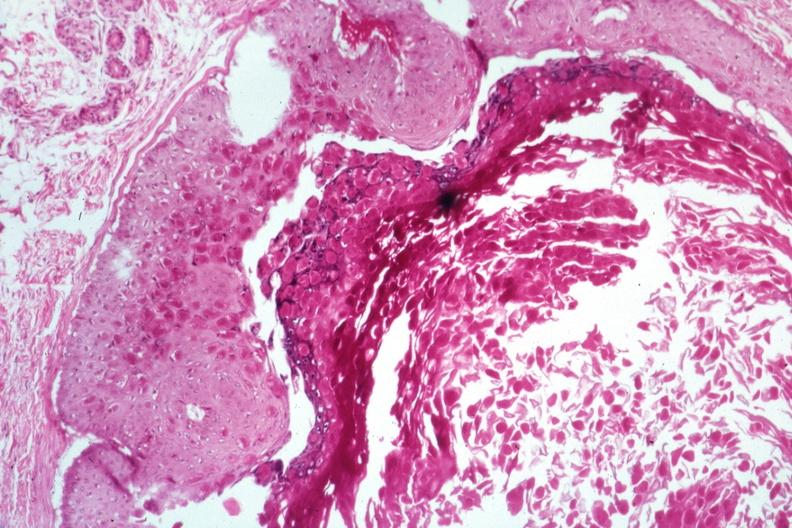does interstitial cell tumor show large inclusion bodies well shown?
Answer the question using a single word or phrase. No 